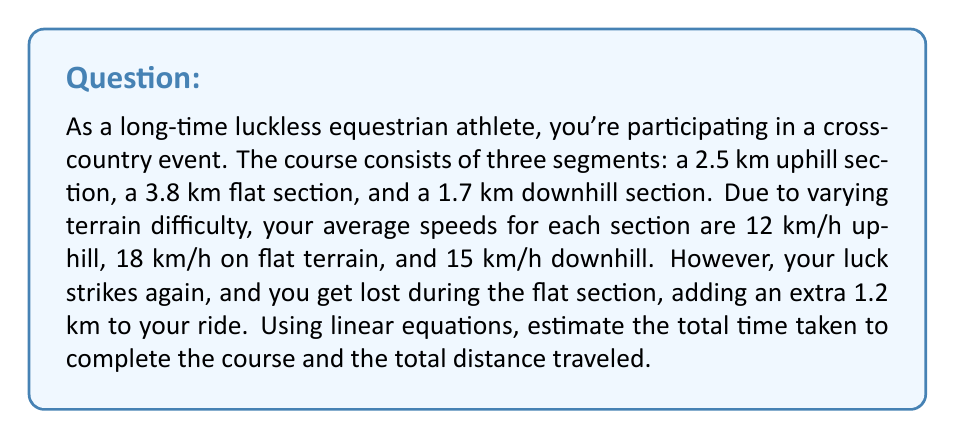Give your solution to this math problem. Let's approach this problem step-by-step using linear equations:

1. First, let's define our variables:
   $t_u$ = time for uphill section
   $t_f$ = time for flat section
   $t_d$ = time for downhill section
   $d_{\text{total}}$ = total distance traveled

2. We can use the equation $\text{Time} = \frac{\text{Distance}}{\text{Speed}}$ for each section:

   Uphill: $t_u = \frac{2.5 \text{ km}}{12 \text{ km/h}} = \frac{5}{24} \text{ h} = 0.2083 \text{ h}$

   Flat (including the extra distance): $t_f = \frac{3.8 \text{ km} + 1.2 \text{ km}}{18 \text{ km/h}} = \frac{5}{18} \text{ h} = 0.2778 \text{ h}$

   Downhill: $t_d = \frac{1.7 \text{ km}}{15 \text{ km/h}} = \frac{17}{150} \text{ h} = 0.1133 \text{ h}$

3. The total time is the sum of these times:
   $$t_{\text{total}} = t_u + t_f + t_d = 0.2083 + 0.2778 + 0.1133 = 0.5994 \text{ h}$$

4. To convert this to hours and minutes:
   0.5994 hours = 35.964 minutes ≈ 36 minutes

5. The total distance traveled is the sum of all sections, including the extra distance:
   $$d_{\text{total}} = 2.5 \text{ km} + 3.8 \text{ km} + 1.2 \text{ km} + 1.7 \text{ km} = 9.2 \text{ km}$$
Answer: The total time taken to complete the course is approximately 36 minutes, and the total distance traveled is 9.2 km. 